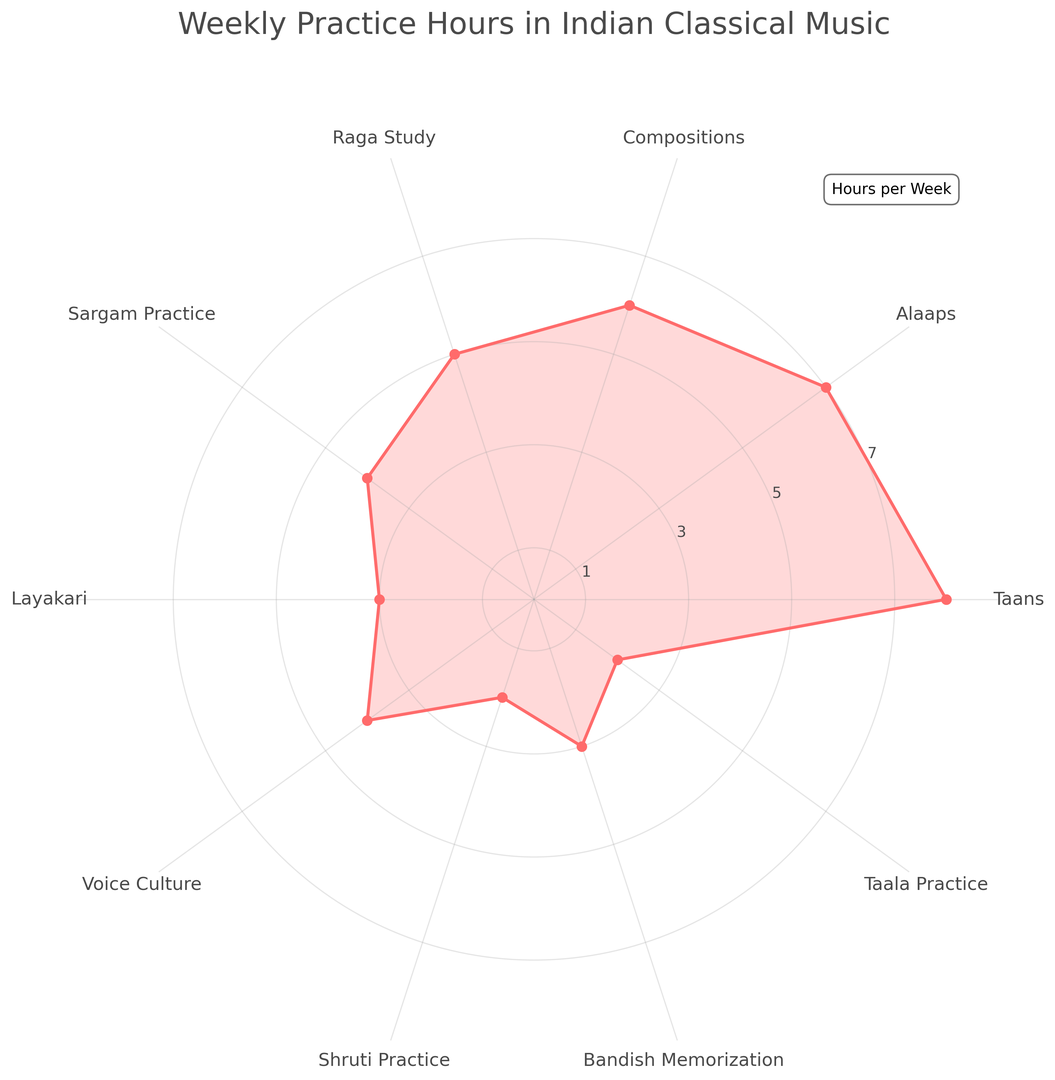What aspect has the highest weekly practice hours? The value at the end of the tallest segment indicates the aspect with the highest weekly practice hours. It reaches 8 hours per week.
Answer: Taans Which aspect has the lowest weekly practice hours? The value at the end of the shortest segment indicates the aspect with the lowest weekly practice hours. It reaches 2 hours per week.
Answer: Shruti Practice and Taala Practice Compare the practice hours for Alaaps and Raga Study. Which one is higher, and by how much? Alaaps have 7 hours, and Raga Study has 5 hours. The difference is 7 - 5 = 2 hours.
Answer: Alaaps by 2 hours What is the total amount of time spent on Compositions, Bandish Memorization, and Taala Practice? Add the hours for each aspect: Compositions (6) + Bandish Memorization (3) + Taala Practice (2). The total is 6 + 3 + 2 = 11 hours.
Answer: 11 hours Which aspect has the same practice hours as Voice Culture? Identify the segment that reaches 4 hours, which corresponds to Voice Culture, and see which other segment also reaches 4 hours.
Answer: Sargam Practice What is the average weekly practice time across all aspects? Add all hours and divide by the number of aspects. The sum is 8 + 7 + 6 + 5 + 4 + 3 + 4 + 2 + 3 + 2 = 44. There are 10 aspects: 44 / 10 = 4.4 hours.
Answer: 4.4 hours Which two aspects have equal practice hours, and what are the hours? Look for segments that reach the same height. Both Voice Culture and Sargam Practice reach 4 hours.
Answer: Voice Culture and Sargam Practice with 4 hours Is the practice time for Layakari more or less than for Sargam Practice, and by how much? Layakari has 3 hours, and Sargam Practice has 4 hours. The difference is 4 - 3 = 1 hour.
Answer: Less by 1 hour 